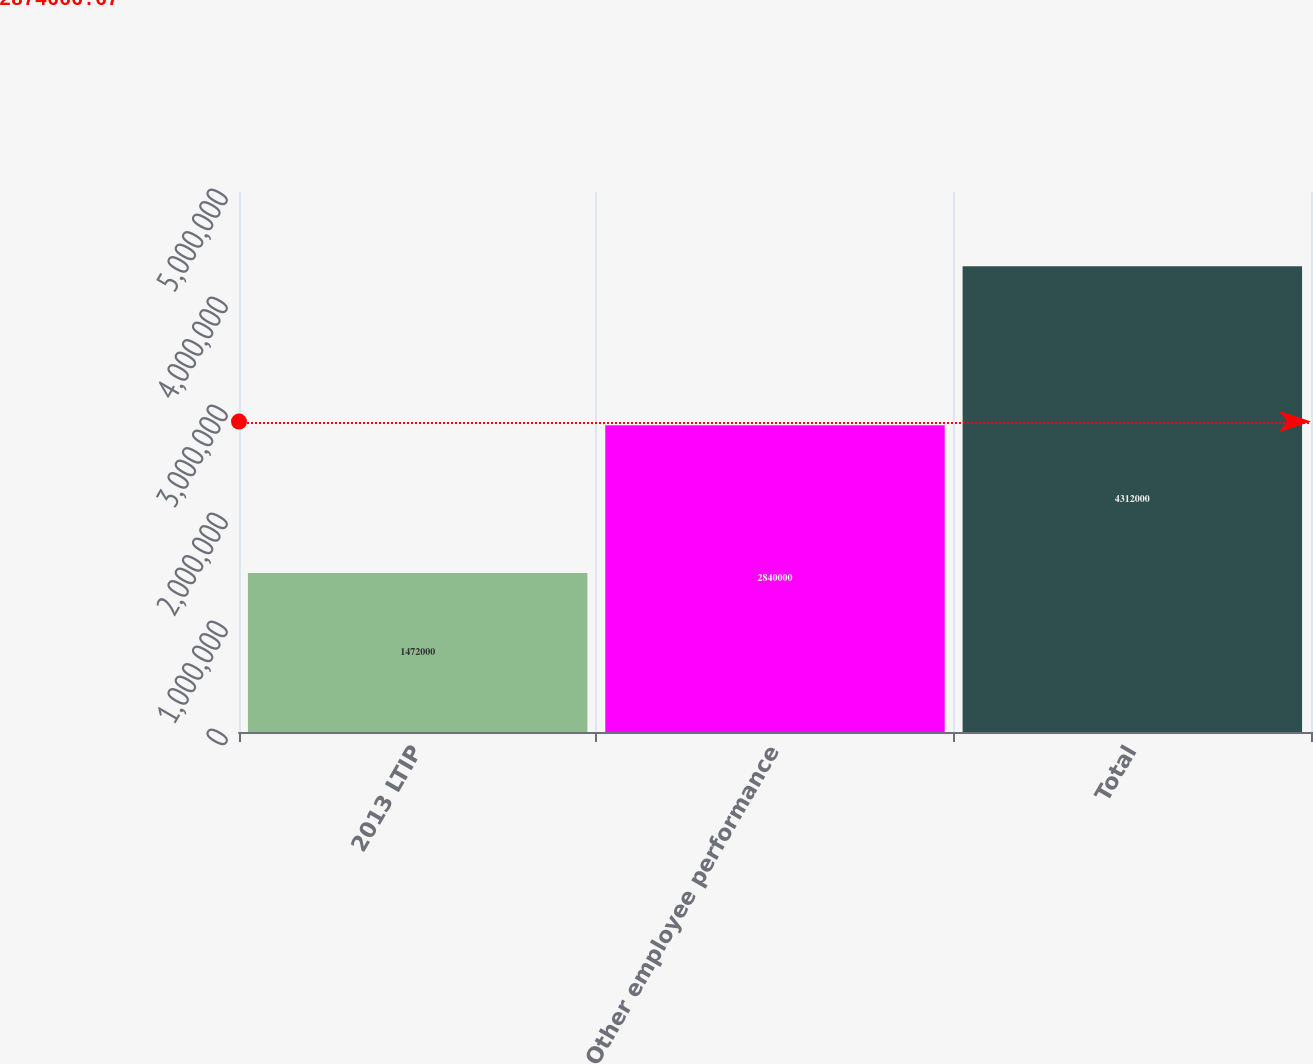Convert chart to OTSL. <chart><loc_0><loc_0><loc_500><loc_500><bar_chart><fcel>2013 LTIP<fcel>Other employee performance<fcel>Total<nl><fcel>1.472e+06<fcel>2.84e+06<fcel>4.312e+06<nl></chart> 